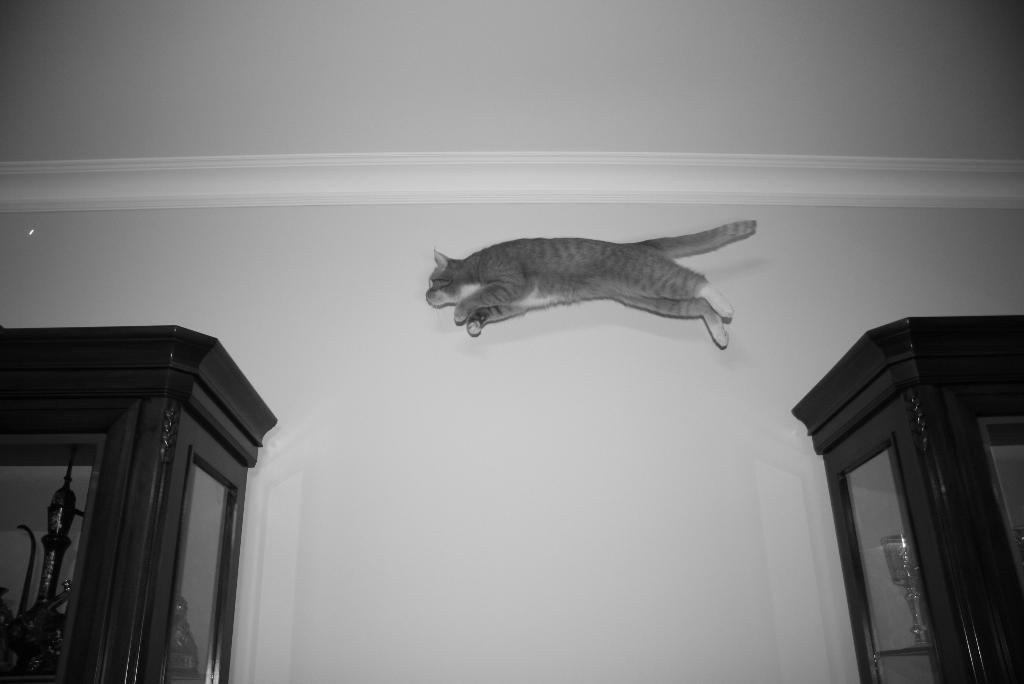How many cupboards are present in the image? There are two cupboards in the image. What is the cat doing in the image? A cat is jumping between the cupboards in the image. What can be seen in the background of the image? There is a wall visible in the background of the image. What type of flowers can be seen growing on the island in the image? There is no island or flowers present in the image; it features two cupboards and a cat jumping between them. 